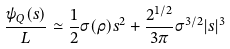Convert formula to latex. <formula><loc_0><loc_0><loc_500><loc_500>\frac { \psi _ { Q } ( s ) } { L } \simeq \frac { 1 } { 2 } \sigma ( \rho ) s ^ { 2 } + \frac { 2 ^ { 1 / 2 } } { 3 \pi } \sigma ^ { 3 / 2 } | s | ^ { 3 }</formula> 